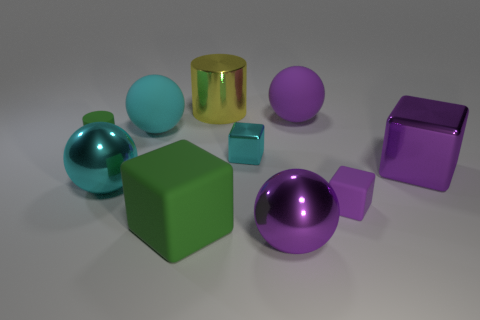Subtract all balls. How many objects are left? 6 Subtract 0 blue cylinders. How many objects are left? 10 Subtract all cyan matte cubes. Subtract all purple blocks. How many objects are left? 8 Add 9 tiny metallic things. How many tiny metallic things are left? 10 Add 6 blue rubber things. How many blue rubber things exist? 6 